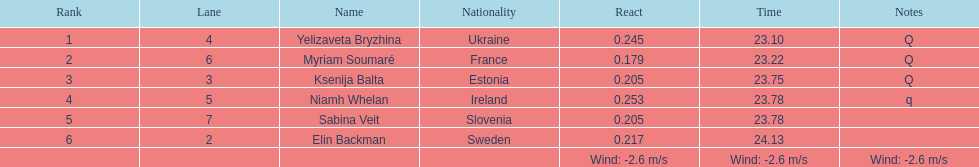The first person to finish in heat 1? Yelizaveta Bryzhina. 